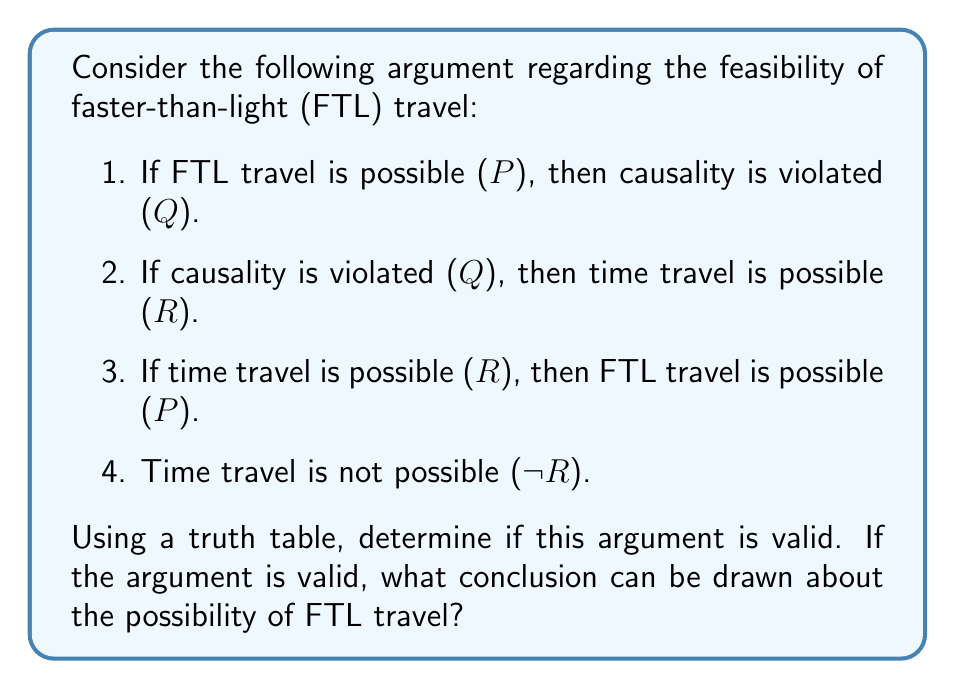Teach me how to tackle this problem. To analyze the validity of this argument, we need to construct a truth table for the given premises and evaluate the conclusion. Let's break it down step by step:

1. First, let's identify the logical statements:
   P: FTL travel is possible
   Q: Causality is violated
   R: Time travel is possible

2. Now, let's translate the premises into logical expressions:
   Premise 1: $P \rightarrow Q$
   Premise 2: $Q \rightarrow R$
   Premise 3: $R \rightarrow P$
   Premise 4: $\neg R$

3. We'll construct a truth table with columns for P, Q, R, and each premise:

   $$
   \begin{array}{|c|c|c|c|c|c|c|}
   \hline
   P & Q & R & P \rightarrow Q & Q \rightarrow R & R \rightarrow P & \neg R \\
   \hline
   T & T & T & T & T & T & F \\
   T & T & F & T & T & T & T \\
   T & F & T & F & T & T & F \\
   T & F & F & F & T & T & T \\
   F & T & T & T & T & F & F \\
   F & T & F & T & T & T & T \\
   F & F & T & T & T & F & F \\
   F & F & F & T & T & T & T \\
   \hline
   \end{array}
   $$

4. Now, we need to find rows where all premises are true (T) simultaneously:

   $$
   \begin{array}{|c|c|c|c|c|c|c|}
   \hline
   P & Q & R & P \rightarrow Q & Q \rightarrow R & R \rightarrow P & \neg R \\
   \hline
   T & T & F & T & T & T & T \\
   F & T & F & T & T & T & T \\
   F & F & F & T & T & T & T \\
   \hline
   \end{array}
   $$

5. We can see that there are three rows where all premises are true. In all of these rows, P is either F or T when R is F. This means that the argument does not conclusively determine the truth value of P (FTL travel possibility).

6. However, we can observe that in all valid rows, R is always F, which is consistent with the given premise that time travel is not possible (¬R).

7. The argument is considered valid because there exists at least one interpretation (in this case, three) where all premises are true simultaneously. However, it does not lead to a definitive conclusion about the possibility of FTL travel.
Answer: The argument is valid, but it does not lead to a definitive conclusion about the possibility of FTL travel. The truth table analysis shows that when all premises are true, FTL travel can be either possible or impossible, while time travel remains impossible. Therefore, based on this argument alone, we cannot determine the feasibility of FTL travel. 